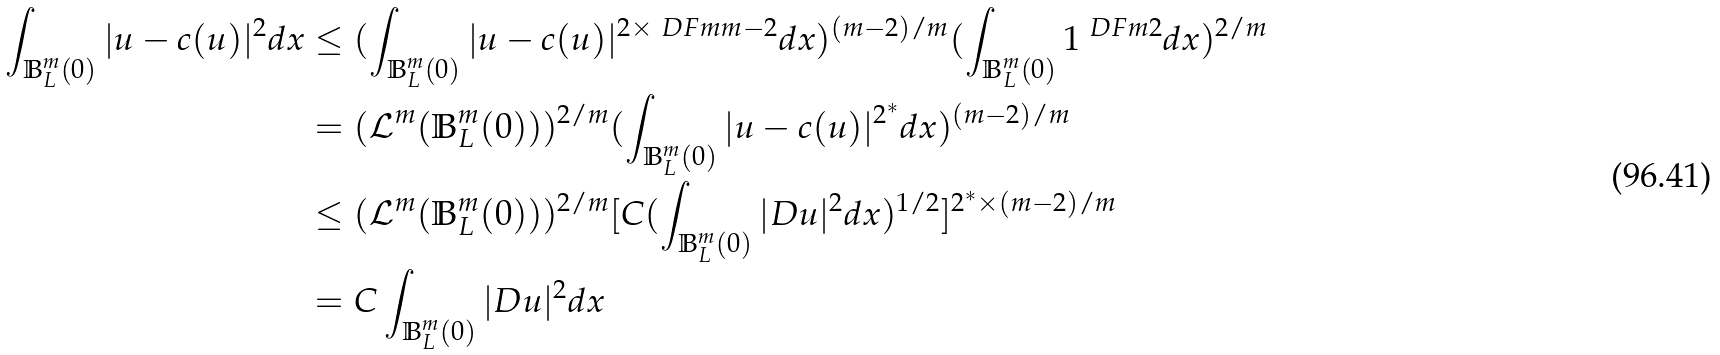<formula> <loc_0><loc_0><loc_500><loc_500>\int _ { \mathbb { B } _ { L } ^ { m } ( 0 ) } | u - c ( u ) | ^ { 2 } d x & \leq ( \int _ { \mathbb { B } _ { L } ^ { m } ( 0 ) } | u - c ( u ) | ^ { 2 \times \ D F { m } { m - 2 } } d x ) ^ { ( m - 2 ) / m } ( \int _ { \mathbb { B } _ { L } ^ { m } ( 0 ) } 1 ^ { \ D F { m } { 2 } } d x ) ^ { 2 / m } \\ & = ( \mathcal { L } ^ { m } ( \mathbb { B } _ { L } ^ { m } ( 0 ) ) ) ^ { 2 / m } ( \int _ { \mathbb { B } _ { L } ^ { m } ( 0 ) } | u - c ( u ) | ^ { 2 ^ { * } } d x ) ^ { ( m - 2 ) / m } \\ & \leq ( \mathcal { L } ^ { m } ( \mathbb { B } _ { L } ^ { m } ( 0 ) ) ) ^ { 2 / m } [ C ( \int _ { \mathbb { B } _ { L } ^ { m } ( 0 ) } | D u | ^ { 2 } d x ) ^ { 1 / 2 } ] ^ { 2 ^ { * } \times ( m - 2 ) / m } \\ & = C \int _ { \mathbb { B } _ { L } ^ { m } ( 0 ) } | D u | ^ { 2 } d x</formula> 